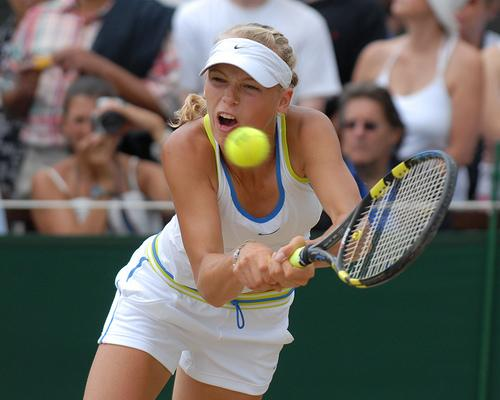In the multi-choice VQA task, is the man wearing a green or blue shirt? The man is wearing a blue shirt. For the visual entailment task, do any of the tennis players wear a bracelet? If so, who does? Yes, the female tennis player wears a bracelet on her arm. Can you describe the two people in the image who are not tennis players? Include their clothing and any accessories they have. There is a woman wearing a white tank top, holding a black camera and taking a photo. There is also a man wearing a blue shirt and plaid shirt, with glasses on his face. What is the main color of the tennis ball being used by the players, and how high is it in the air?  The tennis ball is yellow and is at a height of 115 units in the air. For the VQA task, what color is the sun visor on the woman's head? The sun visor on the woman's head is white. Can you describe any unique features of the female player's outfit, including any colors and patterns found? The female player's outfit includes a white tank top with blue and white edging, white shorts with blue and yellow stripes at the waistband, and a white visor on her head. As a product advertisement task, describe the tennis racket used by the woman. The woman's tennis racket is black, yellow, and blue and held firmly in her hands during the match. What activity are the tennis players engaged in? What kind of clothing are they wearing? The tennis players are playing tennis, with the woman hitting the ball in the air. They are wearing white tank tops, white shorts, and visors during the match. 